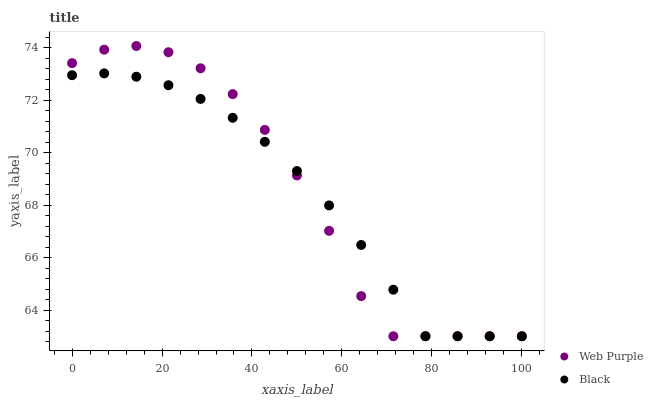Does Black have the minimum area under the curve?
Answer yes or no. Yes. Does Web Purple have the maximum area under the curve?
Answer yes or no. Yes. Does Black have the maximum area under the curve?
Answer yes or no. No. Is Black the smoothest?
Answer yes or no. Yes. Is Web Purple the roughest?
Answer yes or no. Yes. Is Black the roughest?
Answer yes or no. No. Does Web Purple have the lowest value?
Answer yes or no. Yes. Does Web Purple have the highest value?
Answer yes or no. Yes. Does Black have the highest value?
Answer yes or no. No. Does Web Purple intersect Black?
Answer yes or no. Yes. Is Web Purple less than Black?
Answer yes or no. No. Is Web Purple greater than Black?
Answer yes or no. No. 